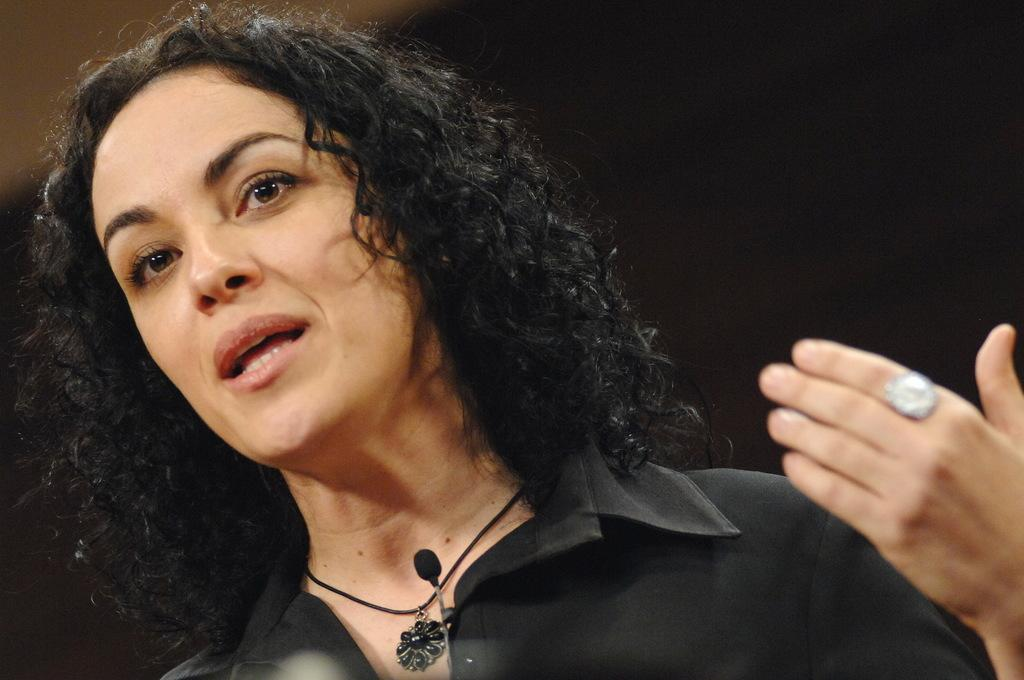Who is the main subject in the image? There is a woman in the image. Where is the woman located in relation to the image? The woman is in the foreground. What might the woman be doing in the image? The woman appears to be talking about something. What type of hair product is the woman using in the image? There is no hair product visible in the image, and the woman's hair is not mentioned in the provided facts. 